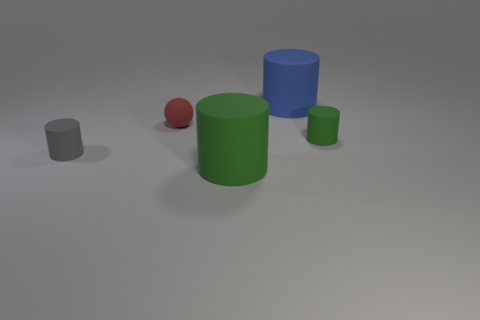What number of large blue cylinders are to the left of the small rubber cylinder that is to the left of the large matte cylinder in front of the small gray cylinder?
Your answer should be compact. 0. What is the material of the small object that is both on the left side of the tiny green matte cylinder and in front of the tiny red matte ball?
Keep it short and to the point. Rubber. Does the tiny ball have the same material as the cylinder in front of the gray rubber object?
Your answer should be compact. Yes. Is the number of tiny green cylinders to the left of the large blue cylinder greater than the number of large green rubber objects behind the small red object?
Keep it short and to the point. No. What is the shape of the red rubber object?
Your answer should be very brief. Sphere. Is the gray cylinder that is left of the red object made of the same material as the big object behind the gray matte cylinder?
Provide a short and direct response. Yes. The small rubber object that is right of the tiny red thing has what shape?
Your answer should be compact. Cylinder. There is a gray thing that is the same shape as the large blue rubber thing; what is its size?
Offer a very short reply. Small. Is there any other thing that has the same shape as the gray matte thing?
Provide a short and direct response. Yes. There is a green rubber object that is behind the small gray matte cylinder; is there a green cylinder that is behind it?
Make the answer very short. No. 